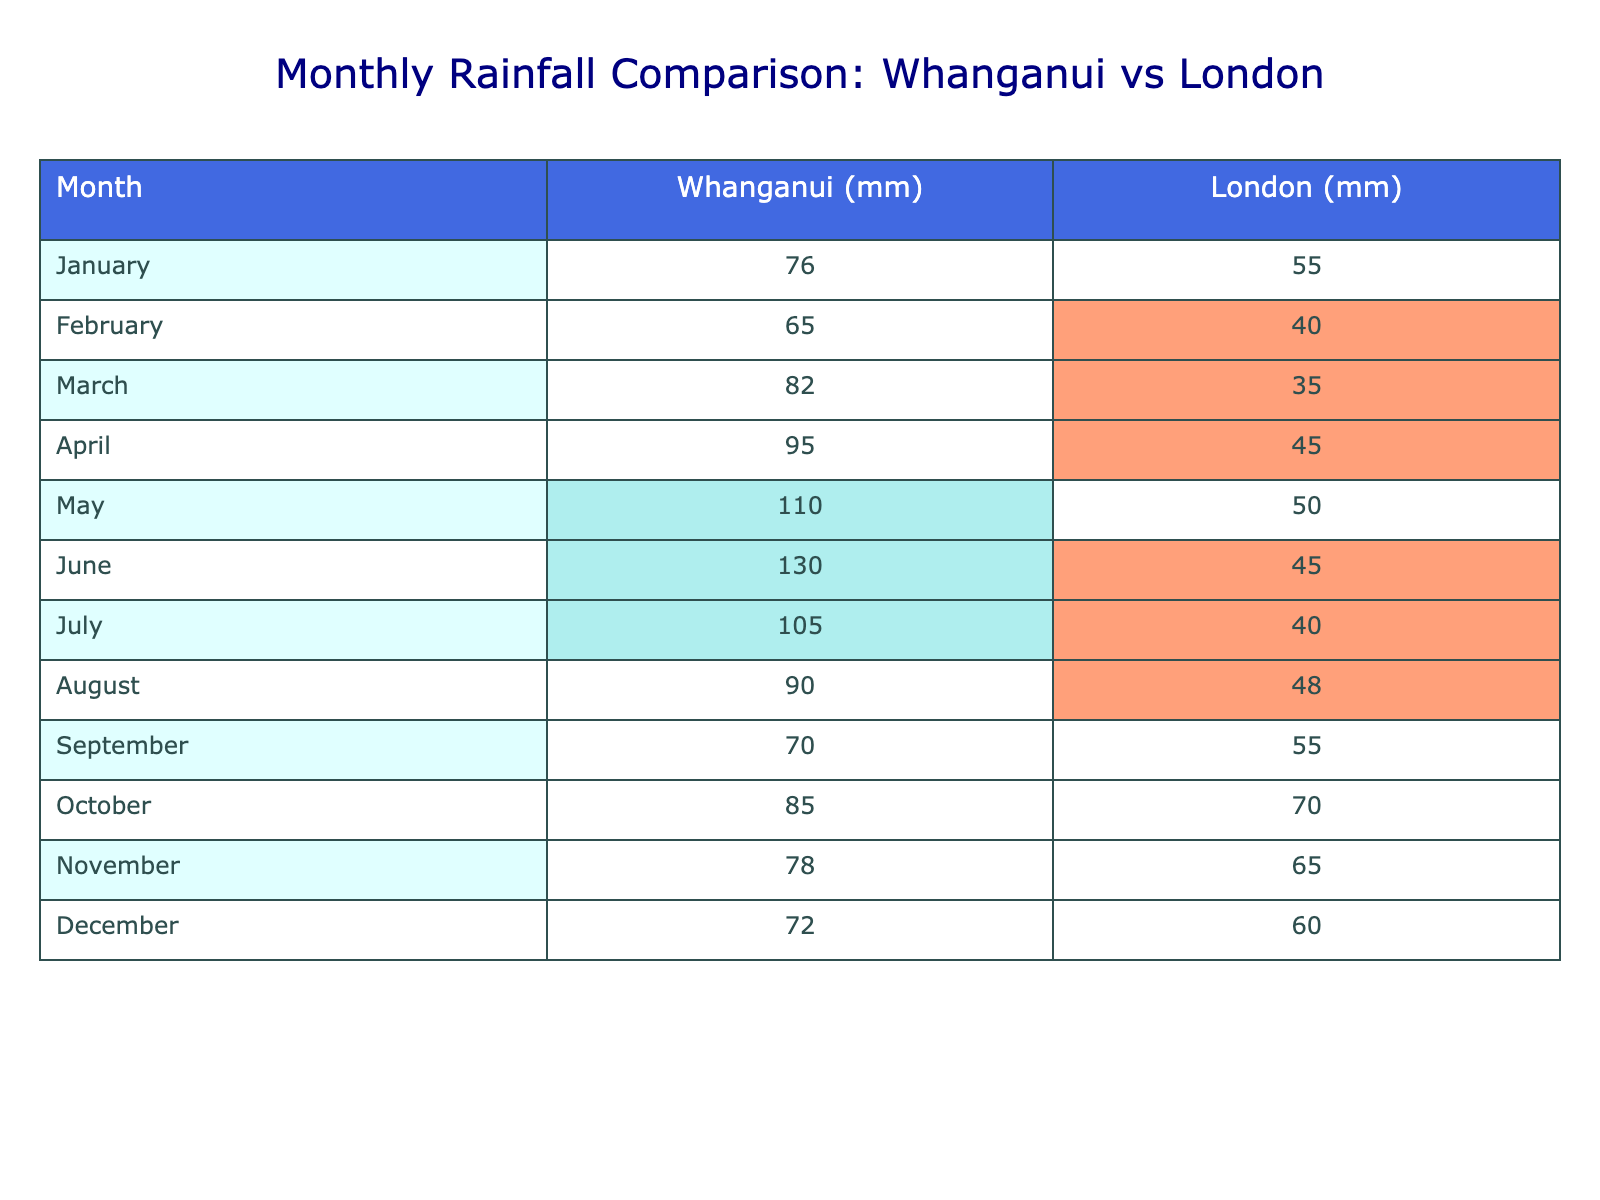What is the total rainfall in Whanganui for the year? To find the total rainfall in Whanganui, we sum all monthly values: (76 + 65 + 82 + 95 + 110 + 130 + 105 + 90 + 70 + 85 + 78 + 72) = 1,181 mm.
Answer: 1,181 mm Which month had the highest rainfall in London? Looking at the London rainfall data, the month with the highest value is October with 70 mm.
Answer: October How much more rainfall did Whanganui receive than London in June? In June, Whanganui received 130 mm and London received 45 mm. The difference is 130 - 45 = 85 mm.
Answer: 85 mm What was the average monthly rainfall in Whanganui? To calculate the average, sum the monthly values (1,181 mm) and divide by 12 (months): 1,181 / 12 = 98.42 mm.
Answer: 98.42 mm Did Whanganui ever have less rainfall than London in any month? Comparing each month, Whanganui had less rainfall than London in no month; the lowest rainfall in Whanganui was 65 mm in February, while London had 40 mm that month.
Answer: No What is the difference in rainfall between May in Whanganui and the average rainfall in London for the year? May rainfall in Whanganui is 110 mm. First, calculate London's total annual rainfall: (55 + 40 + 35 + 45 + 50 + 45 + 40 + 48 + 55 + 70 + 65 + 60) =  585 mm. Then, average it: 585 / 12 = 48.75 mm. The difference is 110 - 48.75 = 61.25 mm.
Answer: 61.25 mm In which month did London have the most comparable rainfall to Whanganui? Comparing the monthly data, August in Whanganui (90 mm) and London (48 mm) show the closest alignment; however, March in both cities shows better similarity. Hence, March in London (35 mm) and Whanganui (82 mm) form a higher discrepancy. The months with the least difference are January in Whanganui (76 mm) and London (55 mm).
Answer: January Which city had the most consistent rainfall month-to-month? Looking for consistency means checking the variation in monthly figures. Whanganui has a range of 130 mm (June) to 65 mm (February), while London’s range is 70 mm (October) to 35 mm (March). London’s figures are lower overall, but Whanganui's show a larger variance.
Answer: London What was the total amount of rainfall from June to August in Whanganui? The total from June to August is: June (130 mm) + July (105 mm) + August (90 mm) = 325 mm.
Answer: 325 mm True or False: The rainfall in Whanganui was never below 70 mm in any month. Reviewing the data, February had the lowest rainfall in Whanganui at 65 mm, which means the statement is false.
Answer: False What was the average monthly rainfall for London during the coldest month? Assuming coldest month refers to winter, we check December (60 mm), January (55 mm), and February (40 mm). The average is (60 + 55 + 40) / 3 = 51.67 mm.
Answer: 51.67 mm 